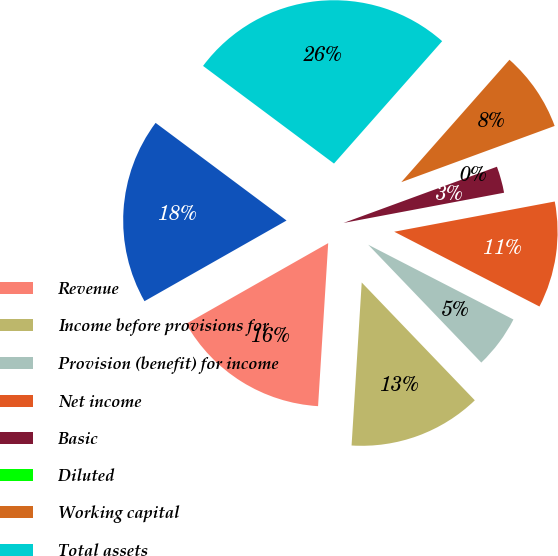Convert chart to OTSL. <chart><loc_0><loc_0><loc_500><loc_500><pie_chart><fcel>Revenue<fcel>Income before provisions for<fcel>Provision (benefit) for income<fcel>Net income<fcel>Basic<fcel>Diluted<fcel>Working capital<fcel>Total assets<fcel>Stockholders' equity<nl><fcel>15.79%<fcel>13.16%<fcel>5.26%<fcel>10.53%<fcel>2.63%<fcel>0.0%<fcel>7.89%<fcel>26.32%<fcel>18.42%<nl></chart> 